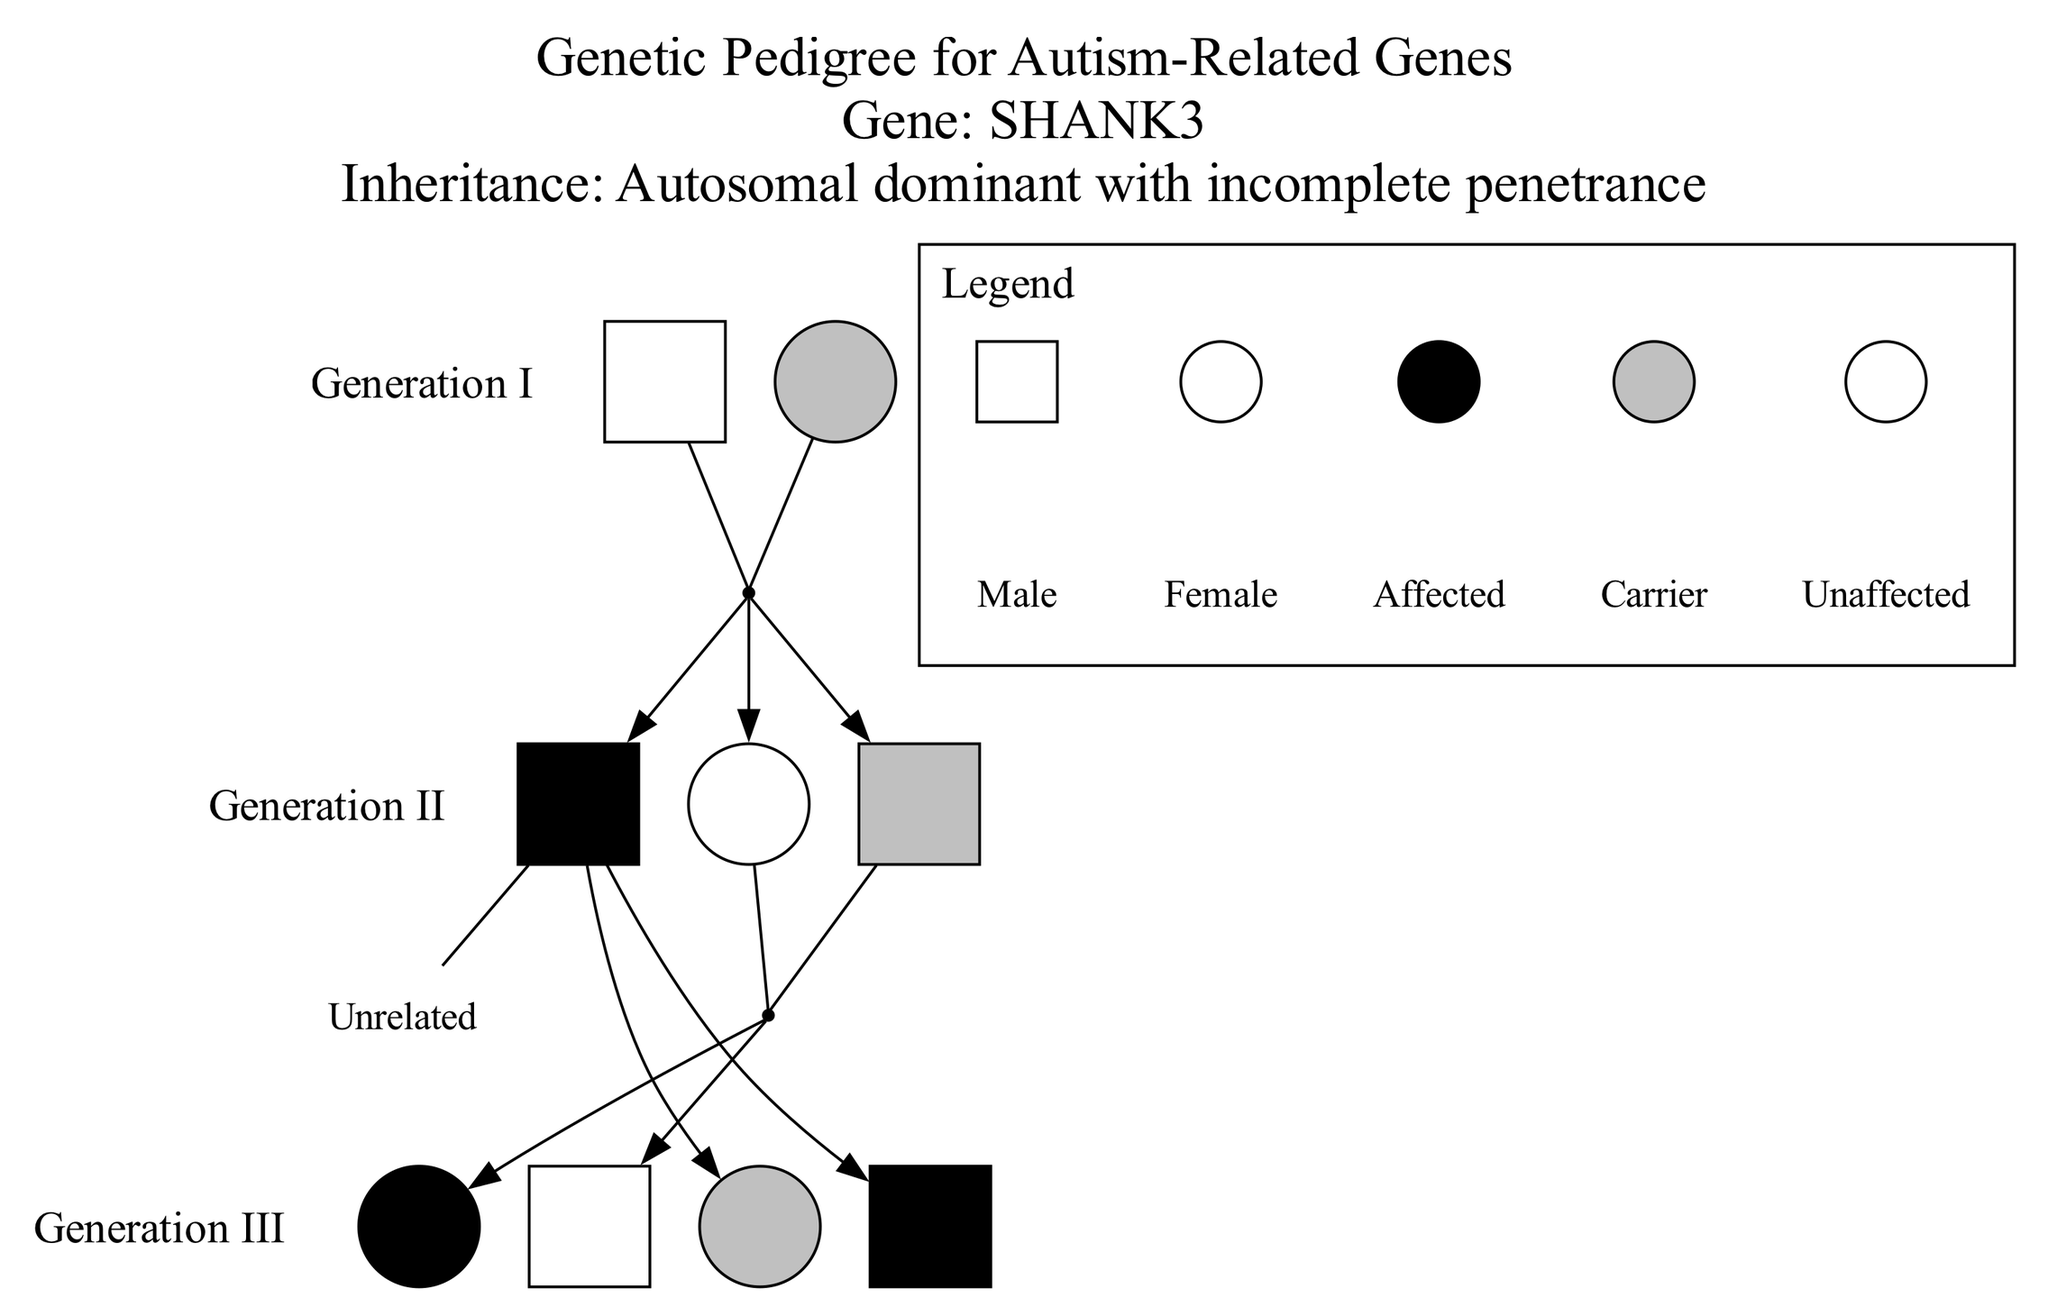What is the status of individual I-2? Individual I-2 is classified as a carrier in the pedigree chart. This can be seen directly under Generation I, where "carrier" is noted for I-2.
Answer: carrier How many males are in Generation II? In Generation II, there are three individuals: II-1 (male, affected), II-2 (female, unaffected), and II-3 (male, carrier). Therefore, counting only the males, we find that there are two males: II-1 and II-3.
Answer: 2 Which individual is the spouse of II-1? The spouse of II-1 is indicated as "Unrelated" in the relationships given in the diagram. We can see this relationship directly under the relationships where II-1 is mentioned.
Answer: Unrelated Who are the affected individuals in Generation III? In Generation III, the affected individuals are III-1 (female, affected) and III-4 (male, affected). By analyzing the status of each individual in this generation, we recognize these two individuals as affected.
Answer: III-1, III-4 How many total individuals are there across all generations? There is a total of 8 individuals mentioned in the pedigree chart: 2 in Generation I, 3 in Generation II, and 4 in Generation III (2+3+4=9).
Answer: 9 If individual II-3 has children with II-2, what is the genetic status of those children? Individual II-3 is a carrier, and II-2 is unaffected. Since the inheritance pattern is autosomal dominant with incomplete penetrance, any potential children could inherit the carrier status from II-3. However, being unaffected themselves means they do not show symptoms of the condition.
Answer: Carrier Which relationship indicates the connection between II-1 and III-3? The relationship between II-1 (affected) and III-3 (female, carrier) is through II-1. II-1 is the parent of III-3 as indicated under the relationships where II-1 has children.
Answer: Parent What is the inheritance pattern of the gene SHANK3? The inheritance pattern for the gene SHANK3, as specified in the diagram, is "autosomal dominant with incomplete penetrance." This descriptor provides insight into how the gene may manifest in individuals.
Answer: autosomal dominant with incomplete penetrance 